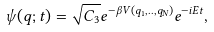Convert formula to latex. <formula><loc_0><loc_0><loc_500><loc_500>\psi ( q ; t ) = \sqrt { C _ { 3 } } e ^ { - \beta V ( q _ { 1 } , . . , q _ { N } ) } e ^ { - i E t } ,</formula> 